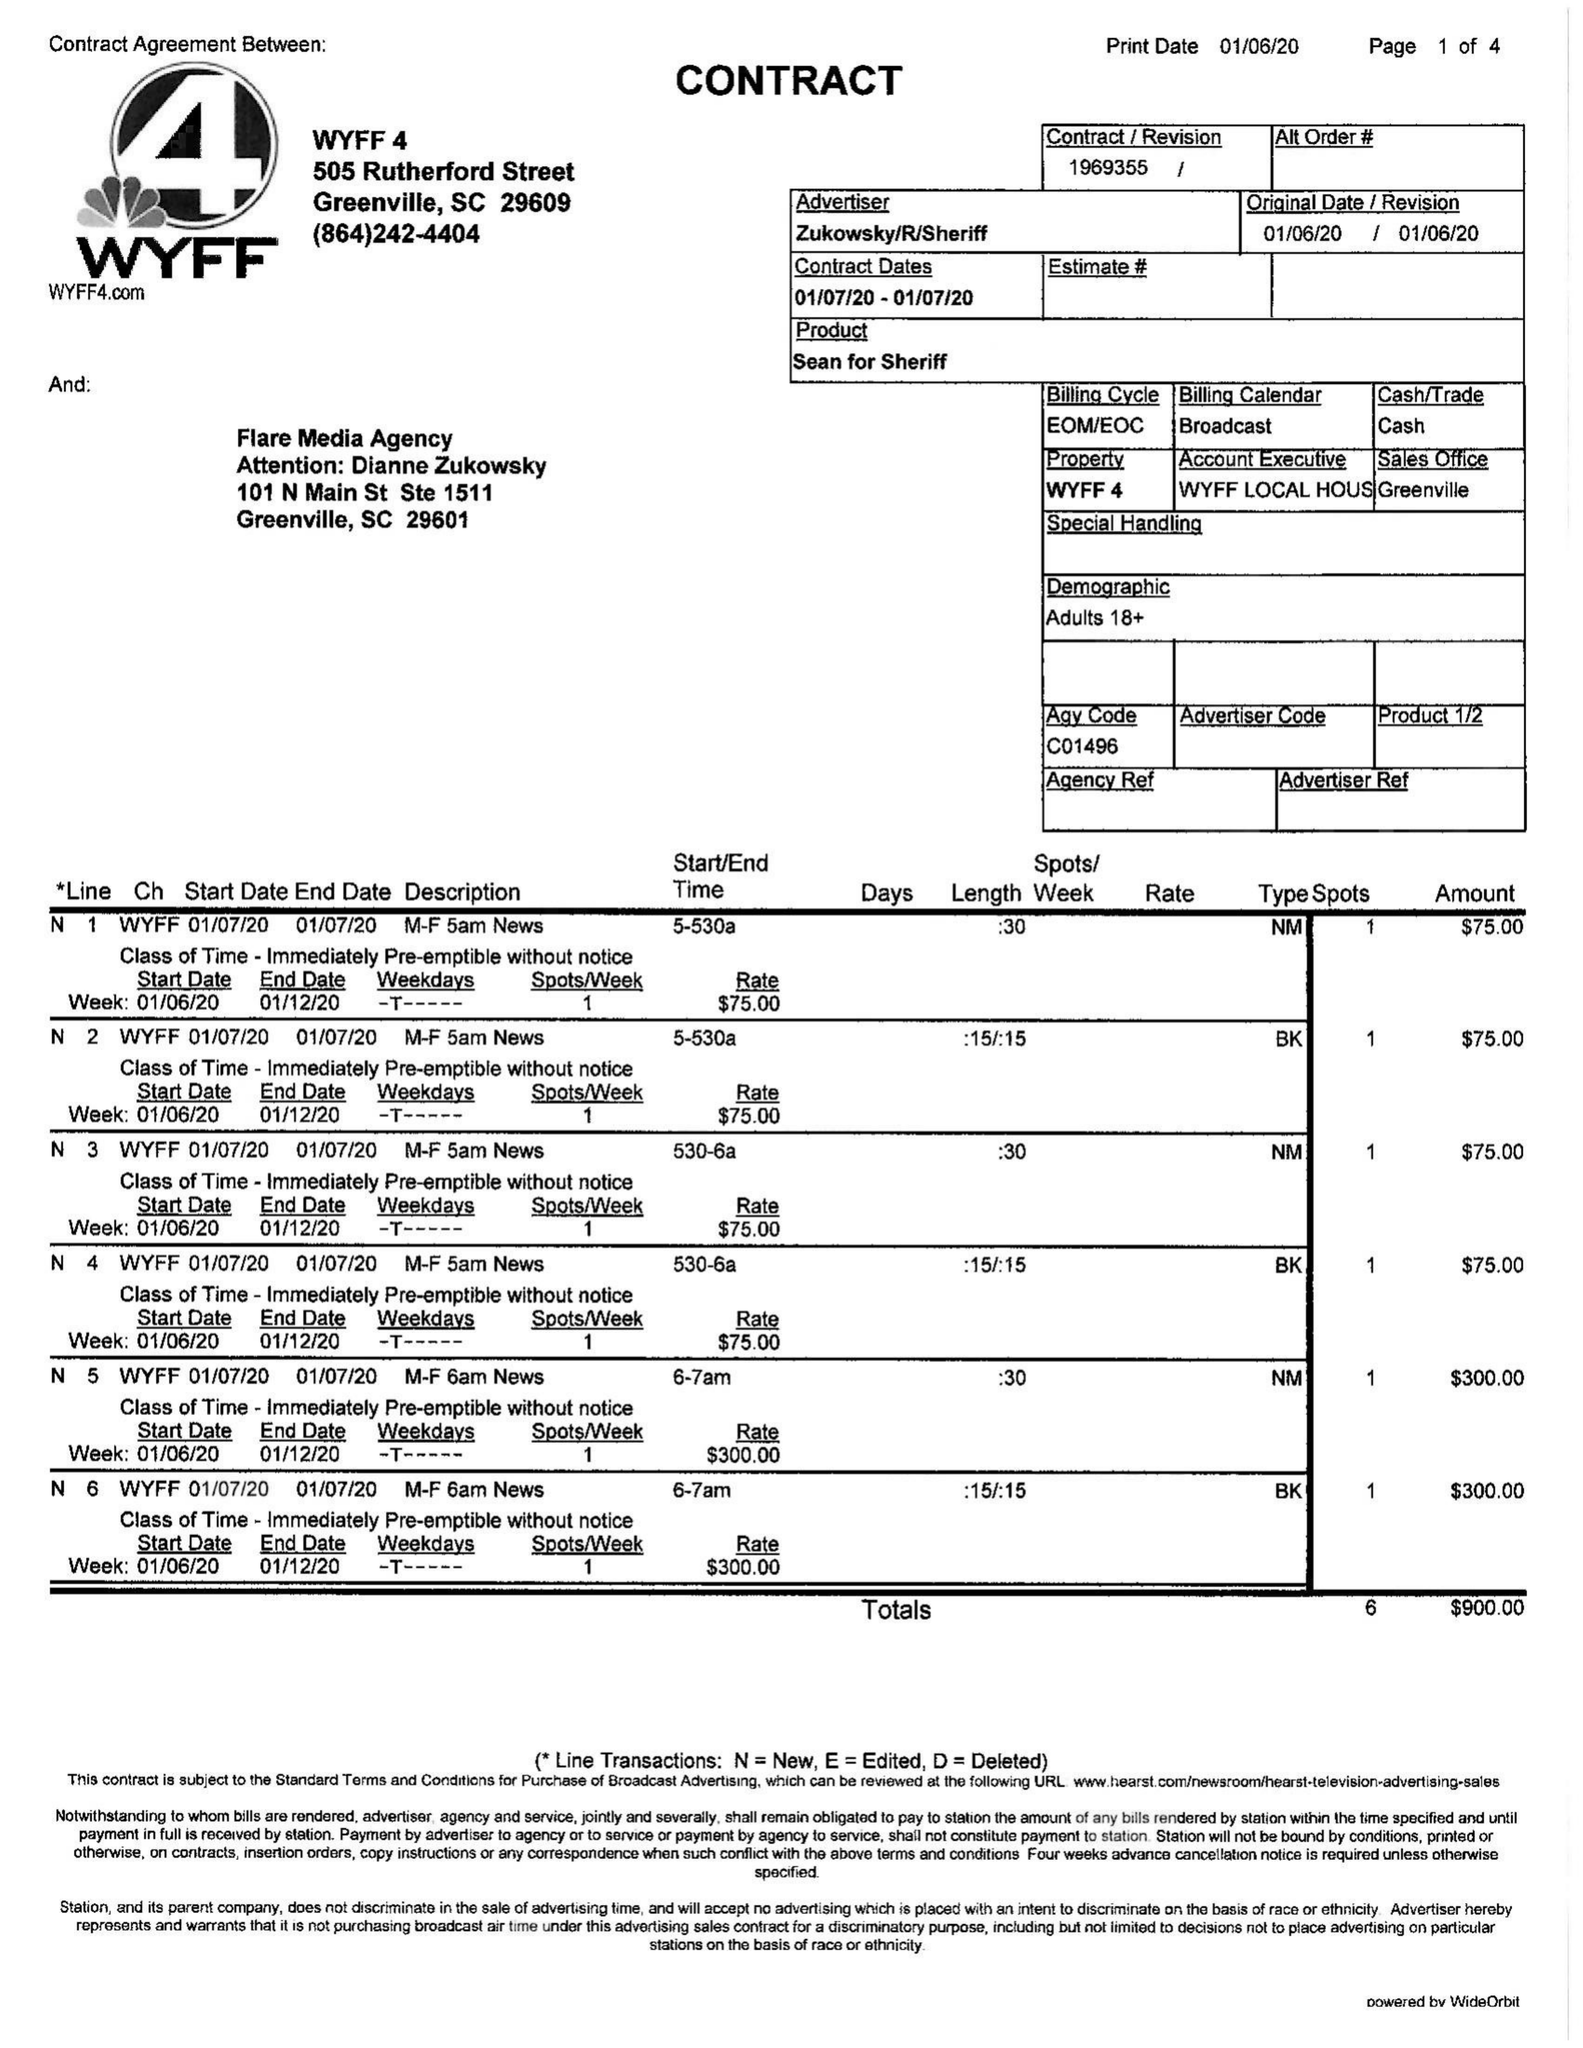What is the value for the advertiser?
Answer the question using a single word or phrase. ZUKOWSKY/R/SHERIFF 